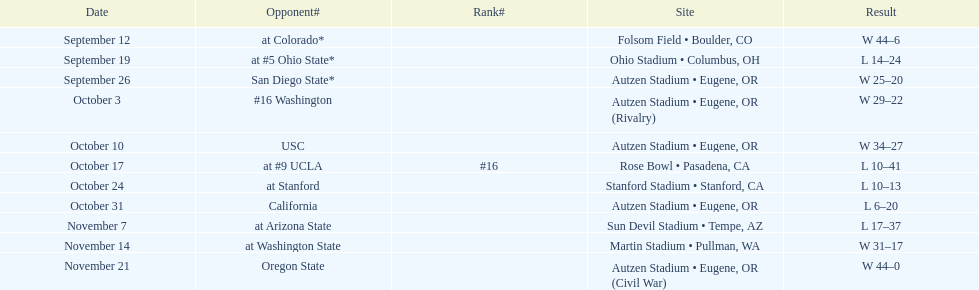How many wins are listed for the season? 6. 